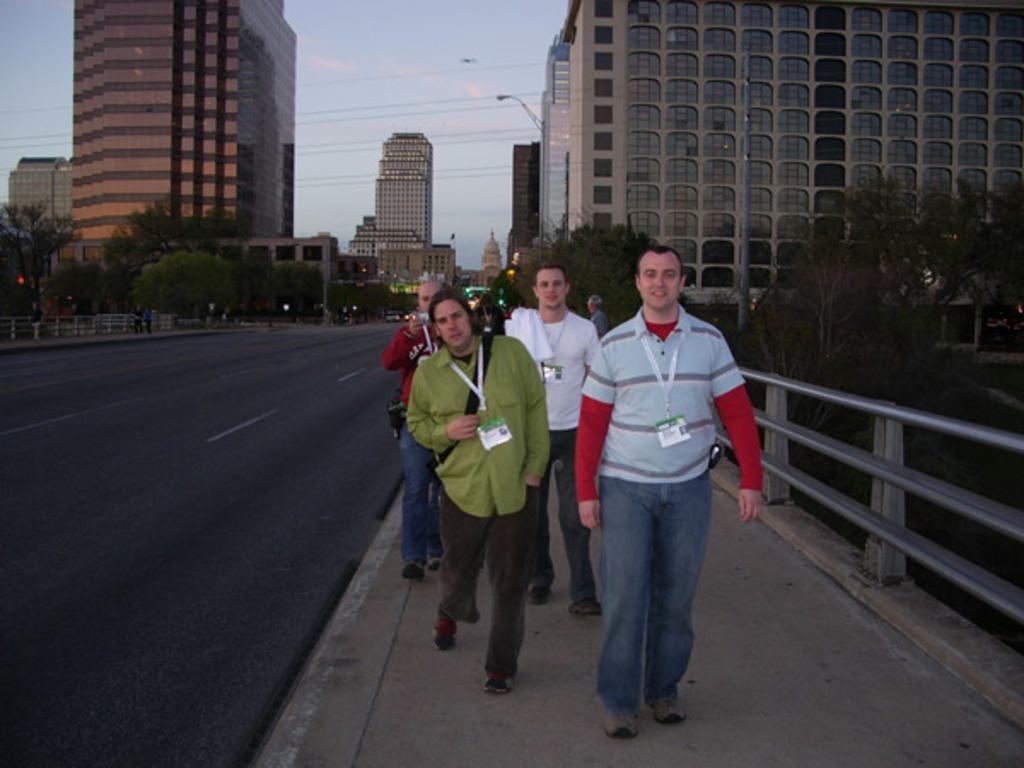What is happening on the road in the image? There are many people walking on the road in the image. What can be seen at the bottom of the image? The road is visible at the bottom of the image. What is visible in the background of the image? There are buildings in the background of the image. What type of vegetation is on the right side of the image? There are small trees on the right side of the image. What is the purpose of the railing on the right side of the image? A railing is present on the right side of the image, possibly for safety or to prevent people from falling. Where is the market located in the image? There is no market present in the image. What type of office can be seen in the image? There is no office present in the image. 